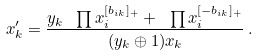<formula> <loc_0><loc_0><loc_500><loc_500>x ^ { \prime } _ { k } = \frac { y _ { k } \ \prod x _ { i } ^ { [ b _ { i k } ] _ { + } } + \ \prod x _ { i } ^ { [ - b _ { i k } ] _ { + } } } { ( y _ { k } \oplus 1 ) x _ { k } } \, .</formula> 